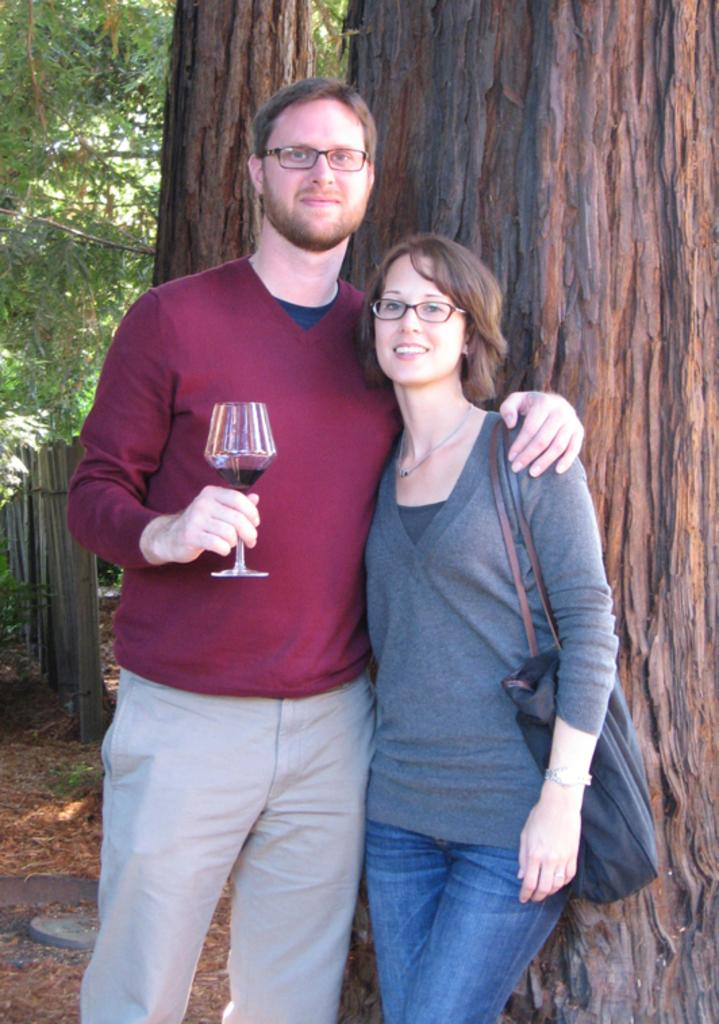Who are the people in the image? There is a man and a woman in the image. What is the man holding in the image? The man is holding a wine glass. What is the woman carrying in the image? The woman is carrying a bag. What can be seen in the background of the image? There is a tree visible behind the people in the image. What type of chicken can be seen in the image? There is no chicken present in the image. How many snails are visible on the tree in the background? There are no snails visible on the tree in the background; only the tree itself is mentioned. 